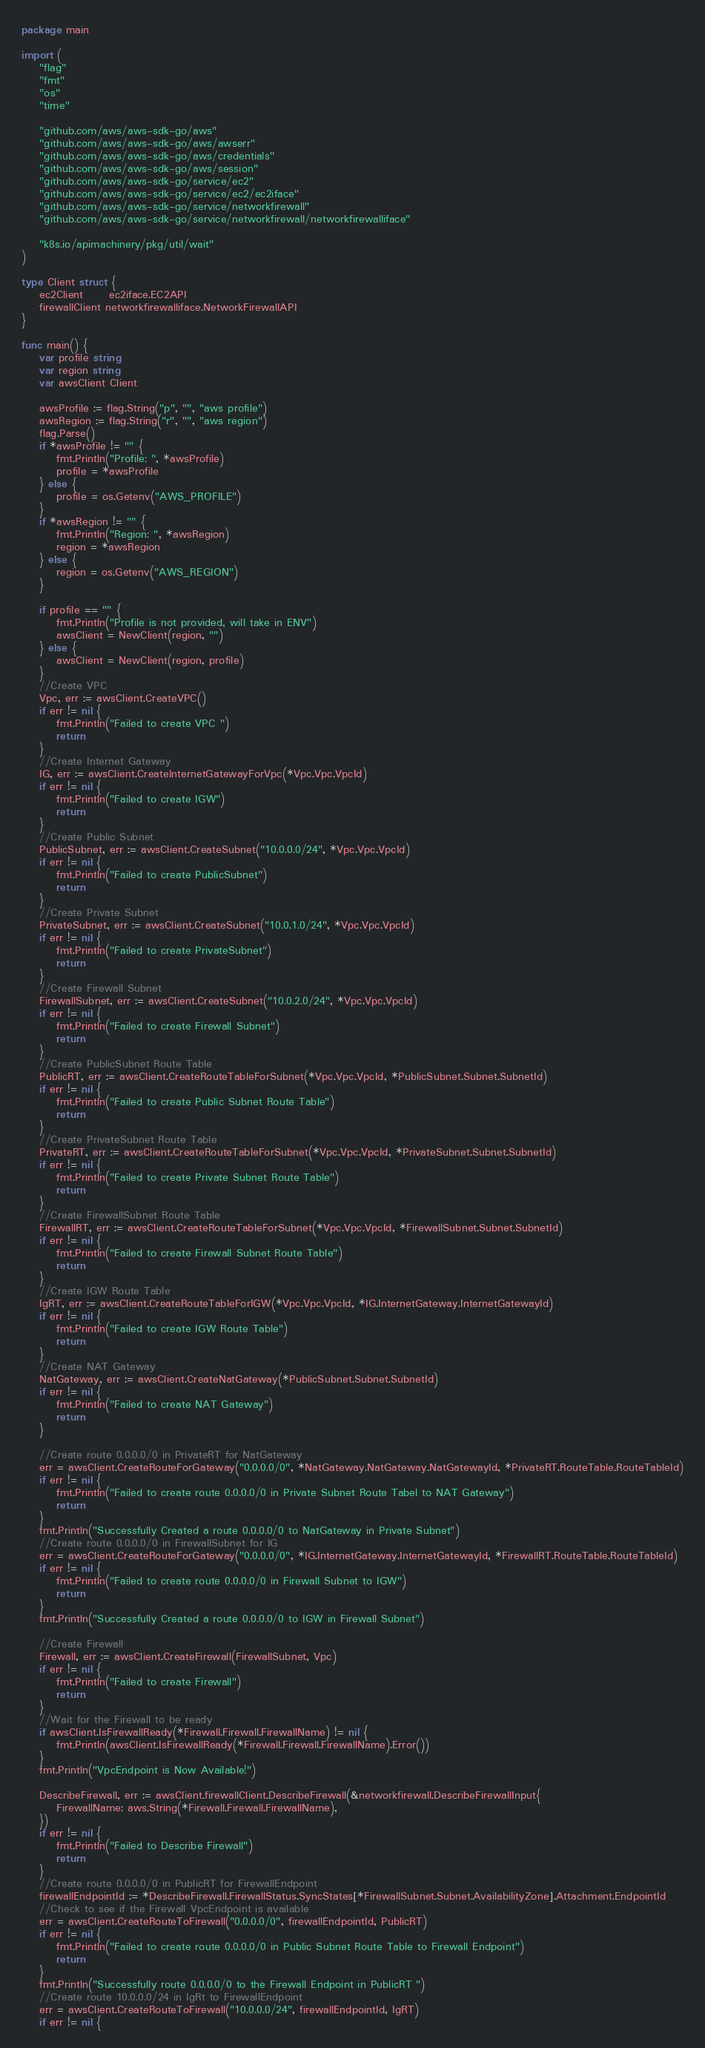Convert code to text. <code><loc_0><loc_0><loc_500><loc_500><_Go_>package main

import (
	"flag"
	"fmt"
	"os"
	"time"

	"github.com/aws/aws-sdk-go/aws"
	"github.com/aws/aws-sdk-go/aws/awserr"
	"github.com/aws/aws-sdk-go/aws/credentials"
	"github.com/aws/aws-sdk-go/aws/session"
	"github.com/aws/aws-sdk-go/service/ec2"
	"github.com/aws/aws-sdk-go/service/ec2/ec2iface"
	"github.com/aws/aws-sdk-go/service/networkfirewall"
	"github.com/aws/aws-sdk-go/service/networkfirewall/networkfirewalliface"

	"k8s.io/apimachinery/pkg/util/wait"
)

type Client struct {
	ec2Client      ec2iface.EC2API
	firewallClient networkfirewalliface.NetworkFirewallAPI
}

func main() {
	var profile string
	var region string
	var awsClient Client

	awsProfile := flag.String("p", "", "aws profile")
	awsRegion := flag.String("r", "", "aws region")
	flag.Parse()
	if *awsProfile != "" {
		fmt.Println("Profile: ", *awsProfile)
		profile = *awsProfile
	} else {
		profile = os.Getenv("AWS_PROFILE")
	}
	if *awsRegion != "" {
		fmt.Println("Region: ", *awsRegion)
		region = *awsRegion
	} else {
		region = os.Getenv("AWS_REGION")
	}

	if profile == "" {
		fmt.Println("Profile is not provided, will take in ENV")
		awsClient = NewClient(region, "")
	} else {
		awsClient = NewClient(region, profile)
	}
	//Create VPC
	Vpc, err := awsClient.CreateVPC()
	if err != nil {
		fmt.Println("Failed to create VPC ")
		return
	}
	//Create Internet Gateway
	IG, err := awsClient.CreateInternetGatewayForVpc(*Vpc.Vpc.VpcId)
	if err != nil {
		fmt.Println("Failed to create IGW")
		return
	}
	//Create Public Subnet
	PublicSubnet, err := awsClient.CreateSubnet("10.0.0.0/24", *Vpc.Vpc.VpcId)
	if err != nil {
		fmt.Println("Failed to create PublicSubnet")
		return
	}
	//Create Private Subnet
	PrivateSubnet, err := awsClient.CreateSubnet("10.0.1.0/24", *Vpc.Vpc.VpcId)
	if err != nil {
		fmt.Println("Failed to create PrivateSubnet")
		return
	}
	//Create Firewall Subnet
	FirewallSubnet, err := awsClient.CreateSubnet("10.0.2.0/24", *Vpc.Vpc.VpcId)
	if err != nil {
		fmt.Println("Failed to create Firewall Subnet")
		return
	}
	//Create PublicSubnet Route Table
	PublicRT, err := awsClient.CreateRouteTableForSubnet(*Vpc.Vpc.VpcId, *PublicSubnet.Subnet.SubnetId)
	if err != nil {
		fmt.Println("Failed to create Public Subnet Route Table")
		return
	}
	//Create PrivateSubnet Route Table
	PrivateRT, err := awsClient.CreateRouteTableForSubnet(*Vpc.Vpc.VpcId, *PrivateSubnet.Subnet.SubnetId)
	if err != nil {
		fmt.Println("Failed to create Private Subnet Route Table")
		return
	}
	//Create FirewallSubnet Route Table
	FirewallRT, err := awsClient.CreateRouteTableForSubnet(*Vpc.Vpc.VpcId, *FirewallSubnet.Subnet.SubnetId)
	if err != nil {
		fmt.Println("Failed to create Firewall Subnet Route Table")
		return
	}
	//Create IGW Route Table
	IgRT, err := awsClient.CreateRouteTableForIGW(*Vpc.Vpc.VpcId, *IG.InternetGateway.InternetGatewayId)
	if err != nil {
		fmt.Println("Failed to create IGW Route Table")
		return
	}
	//Create NAT Gateway
	NatGateway, err := awsClient.CreateNatGateway(*PublicSubnet.Subnet.SubnetId)
	if err != nil {
		fmt.Println("Failed to create NAT Gateway")
		return
	}

	//Create route 0.0.0.0/0 in PrivateRT for NatGateway
	err = awsClient.CreateRouteForGateway("0.0.0.0/0", *NatGateway.NatGateway.NatGatewayId, *PrivateRT.RouteTable.RouteTableId)
	if err != nil {
		fmt.Println("Failed to create route 0.0.0.0/0 in Private Subnet Route Tabel to NAT Gateway")
		return
	}
	fmt.Println("Successfully Created a route 0.0.0.0/0 to NatGateway in Private Subnet")
	//Create route 0.0.0.0/0 in FirewallSubnet for IG
	err = awsClient.CreateRouteForGateway("0.0.0.0/0", *IG.InternetGateway.InternetGatewayId, *FirewallRT.RouteTable.RouteTableId)
	if err != nil {
		fmt.Println("Failed to create route 0.0.0.0/0 in Firewall Subnet to IGW")
		return
	}
	fmt.Println("Successfully Created a route 0.0.0.0/0 to IGW in Firewall Subnet")

	//Create Firewall
	Firewall, err := awsClient.CreateFirewall(FirewallSubnet, Vpc)
	if err != nil {
		fmt.Println("Failed to create Firewall")
		return
	}
	//Wait for the Firewall to be ready
	if awsClient.IsFirewallReady(*Firewall.Firewall.FirewallName) != nil {
		fmt.Println(awsClient.IsFirewallReady(*Firewall.Firewall.FirewallName).Error())
	}
	fmt.Println("VpcEndpoint is Now Available!")

	DescribeFirewall, err := awsClient.firewallClient.DescribeFirewall(&networkfirewall.DescribeFirewallInput{
		FirewallName: aws.String(*Firewall.Firewall.FirewallName),
	})
	if err != nil {
		fmt.Println("Failed to Describe Firewall")
		return
	}
	//Create route 0.0.0.0/0 in PublicRT for FirewallEndpoint
	firewallEndpointId := *DescribeFirewall.FirewallStatus.SyncStates[*FirewallSubnet.Subnet.AvailabilityZone].Attachment.EndpointId
	//Check to see if the Firewall VpcEndpoint is available
	err = awsClient.CreateRouteToFirewall("0.0.0.0/0", firewallEndpointId, PublicRT)
	if err != nil {
		fmt.Println("Failed to create route 0.0.0.0/0 in Public Subnet Route Table to Firewall Endpoint")
		return
	}
	fmt.Println("Successfully route 0.0.0.0/0 to the Firewall Endpoint in PublicRT ")
	//Create route 10.0.0.0/24 in IgRt to FirewallEndpoint
	err = awsClient.CreateRouteToFirewall("10.0.0.0/24", firewallEndpointId, IgRT)
	if err != nil {</code> 